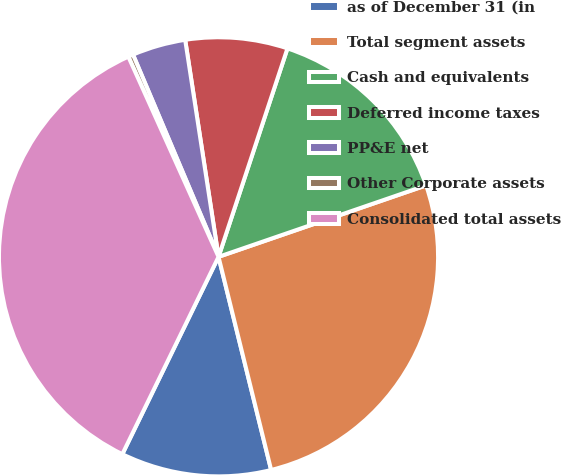Convert chart to OTSL. <chart><loc_0><loc_0><loc_500><loc_500><pie_chart><fcel>as of December 31 (in<fcel>Total segment assets<fcel>Cash and equivalents<fcel>Deferred income taxes<fcel>PP&E net<fcel>Other Corporate assets<fcel>Consolidated total assets<nl><fcel>11.07%<fcel>26.42%<fcel>14.64%<fcel>7.51%<fcel>3.94%<fcel>0.37%<fcel>36.04%<nl></chart> 